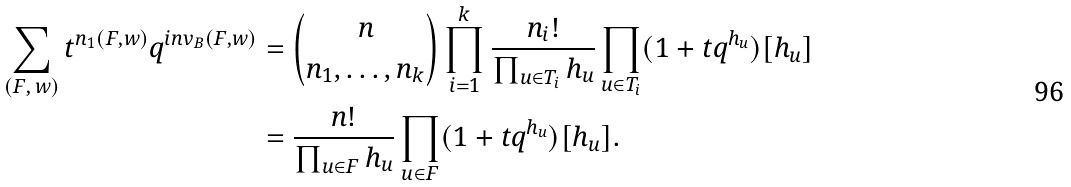<formula> <loc_0><loc_0><loc_500><loc_500>\sum _ { ( F , \, w ) } t ^ { n _ { 1 } ( F , w ) } q ^ { i n v _ { B } ( F , w ) } & = { n \choose { n _ { 1 } , \dots , n _ { k } } } \prod _ { i = 1 } ^ { k } \frac { n _ { i } ! } { \prod _ { u \in T _ { i } } h _ { u } } \prod _ { u \in T _ { i } } ( 1 + t q ^ { h _ { u } } ) [ h _ { u } ] \\ & = \frac { n ! } { \prod _ { u \in F } h _ { u } } \prod _ { u \in F } ( 1 + t q ^ { h _ { u } } ) [ h _ { u } ] .</formula> 